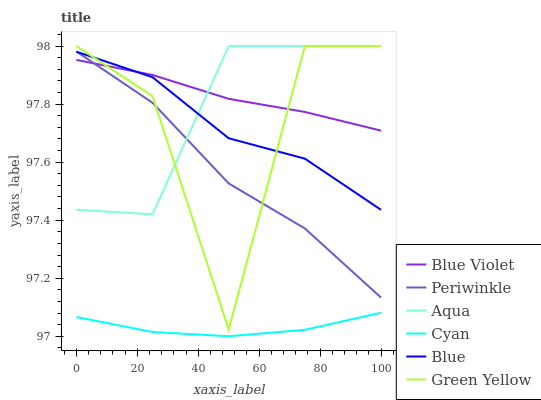Does Cyan have the minimum area under the curve?
Answer yes or no. Yes. Does Blue Violet have the maximum area under the curve?
Answer yes or no. Yes. Does Aqua have the minimum area under the curve?
Answer yes or no. No. Does Aqua have the maximum area under the curve?
Answer yes or no. No. Is Blue Violet the smoothest?
Answer yes or no. Yes. Is Green Yellow the roughest?
Answer yes or no. Yes. Is Aqua the smoothest?
Answer yes or no. No. Is Aqua the roughest?
Answer yes or no. No. Does Cyan have the lowest value?
Answer yes or no. Yes. Does Aqua have the lowest value?
Answer yes or no. No. Does Green Yellow have the highest value?
Answer yes or no. Yes. Does Periwinkle have the highest value?
Answer yes or no. No. Is Cyan less than Blue Violet?
Answer yes or no. Yes. Is Aqua greater than Cyan?
Answer yes or no. Yes. Does Blue Violet intersect Blue?
Answer yes or no. Yes. Is Blue Violet less than Blue?
Answer yes or no. No. Is Blue Violet greater than Blue?
Answer yes or no. No. Does Cyan intersect Blue Violet?
Answer yes or no. No. 